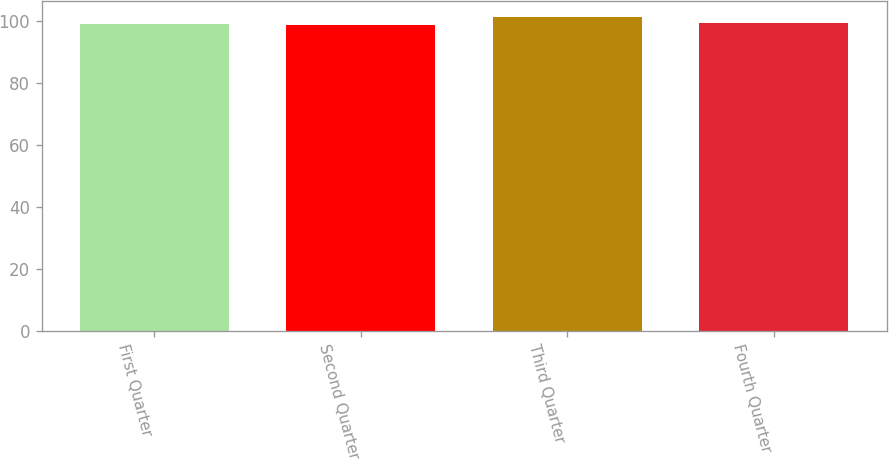Convert chart to OTSL. <chart><loc_0><loc_0><loc_500><loc_500><bar_chart><fcel>First Quarter<fcel>Second Quarter<fcel>Third Quarter<fcel>Fourth Quarter<nl><fcel>98.99<fcel>98.72<fcel>101.27<fcel>99.24<nl></chart> 